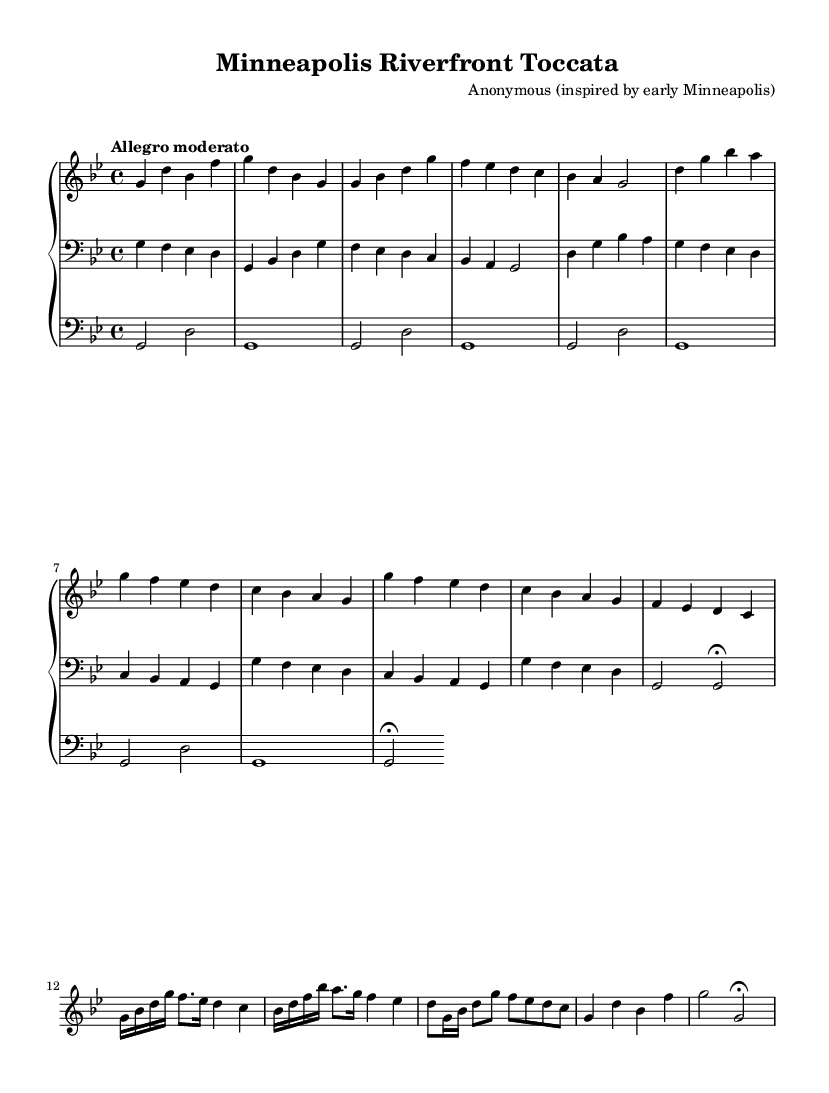What is the key signature of this music? The key signature is indicated at the beginning of the staff; it has two flats, which corresponds to G minor.
Answer: G minor What is the time signature of this piece? The time signature appears at the beginning of the music sheet; it shows 4 over 4, which means four beats in each measure with a quarter note getting one beat.
Answer: 4/4 What is the tempo marking given? The tempo marking is specified at the beginning with the words "Allegro moderato," which indicates a moderately fast speed.
Answer: Allegro moderato How many musical themes are in this piece? By analyzing the structure of the piece as indicated in the music, there are three distinct themes labeled as Theme A, Theme B, and Theme C.
Answer: Three What is the form of the piece? The piece exhibits a form that includes an introduction, multiple themes, a development section, and a coda – common structures in Baroque compositions.
Answer: Toccata form What kind of musical instrument is this piece written for? The notation includes a "PianoStaff" and specific clefs for both hands and pedal, indicating that it is composed for an organ, especially highlighting technique common in Baroque music.
Answer: Organ What historical landmarks does this piece evoke? The themes are named after significant landmarks of early Minneapolis, such as the Stone Arch Bridge, Mill City, and St. Anthony Falls, connecting the music to local geography and history.
Answer: Stone Arch Bridge, Mill City, St. Anthony Falls 